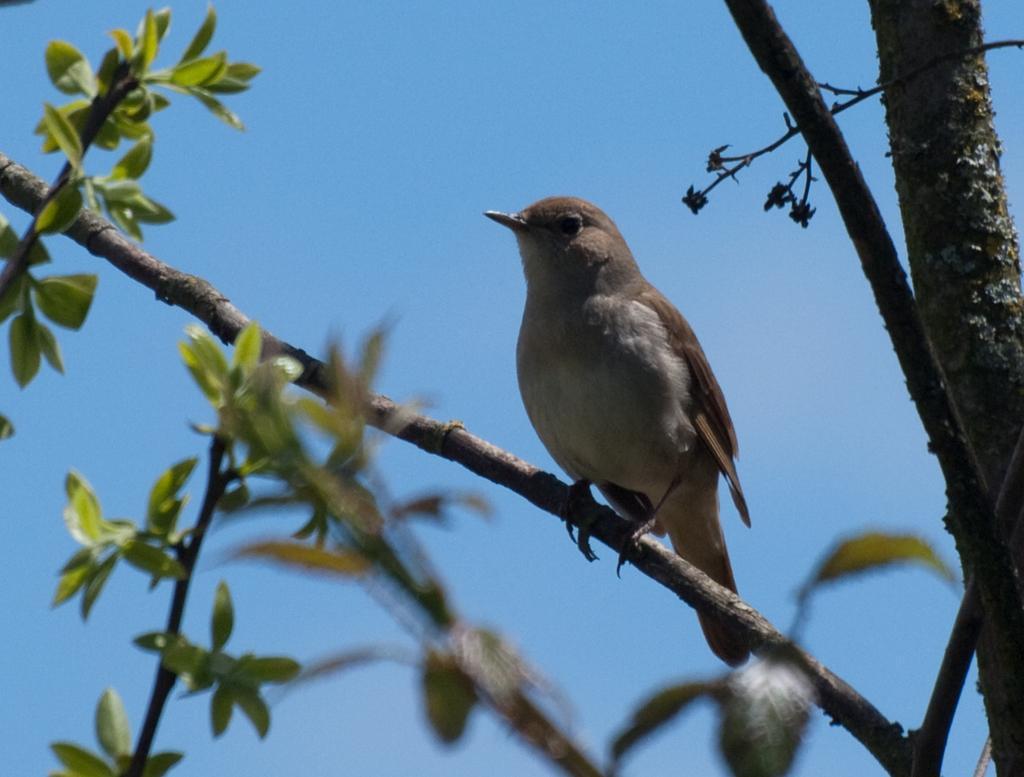Describe this image in one or two sentences. In this image I can see a bird which is cream and brown in color on the tree which is brown and green in color. In the background I can see the sky. 